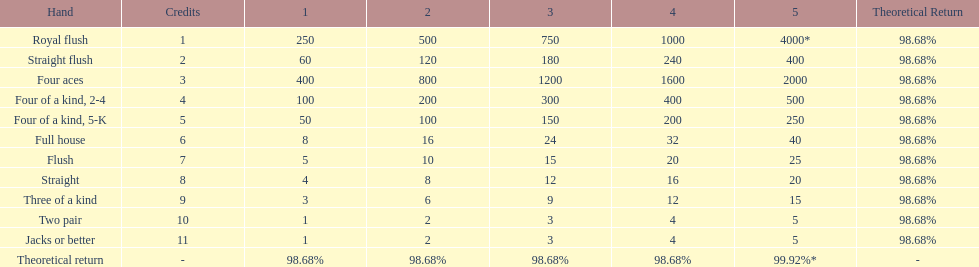Each four aces win is a multiple of what number? 400. 